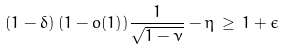<formula> <loc_0><loc_0><loc_500><loc_500>( 1 - \delta ) \, ( 1 - o ( 1 ) ) \frac { 1 } { \sqrt { 1 - \nu } } - \eta \, \geq \, 1 + \epsilon</formula> 